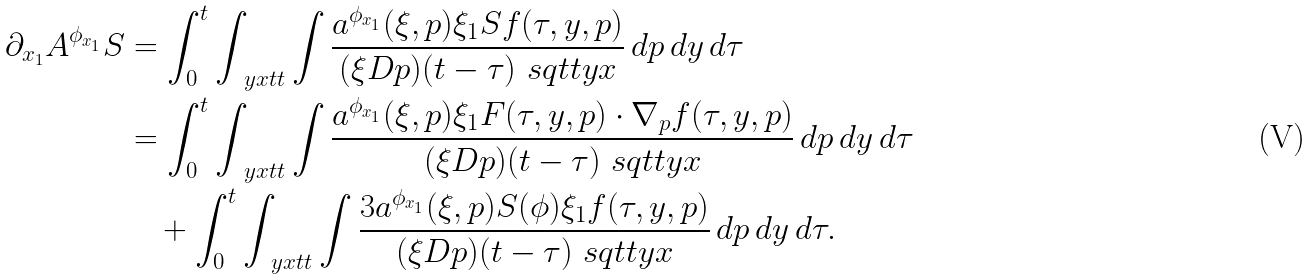Convert formula to latex. <formula><loc_0><loc_0><loc_500><loc_500>\partial _ { x _ { 1 } } A ^ { \phi _ { x _ { 1 } } } S & = \int ^ { t } _ { 0 } \int _ { \ y x t t } \int \frac { a ^ { \phi _ { x _ { 1 } } } ( \xi , p ) \xi _ { 1 } S f ( \tau , y , p ) } { ( \xi D p ) ( t - \tau ) \ s q t t y x } \, d p \, d y \, d \tau \\ & = \int ^ { t } _ { 0 } \int _ { \ y x t t } \int \frac { a ^ { \phi _ { x _ { 1 } } } ( \xi , p ) \xi _ { 1 } F ( \tau , y , p ) \cdot \nabla _ { p } f ( \tau , y , p ) } { ( \xi D p ) ( t - \tau ) \ s q t t y x } \, d p \, d y \, d \tau \\ & \quad + \int ^ { t } _ { 0 } \int _ { \ y x t t } \int \frac { 3 a ^ { \phi _ { x _ { 1 } } } ( \xi , p ) S ( \phi ) \xi _ { 1 } f ( \tau , y , p ) } { ( \xi D p ) ( t - \tau ) \ s q t t y x } \, d p \, d y \, d \tau .</formula> 